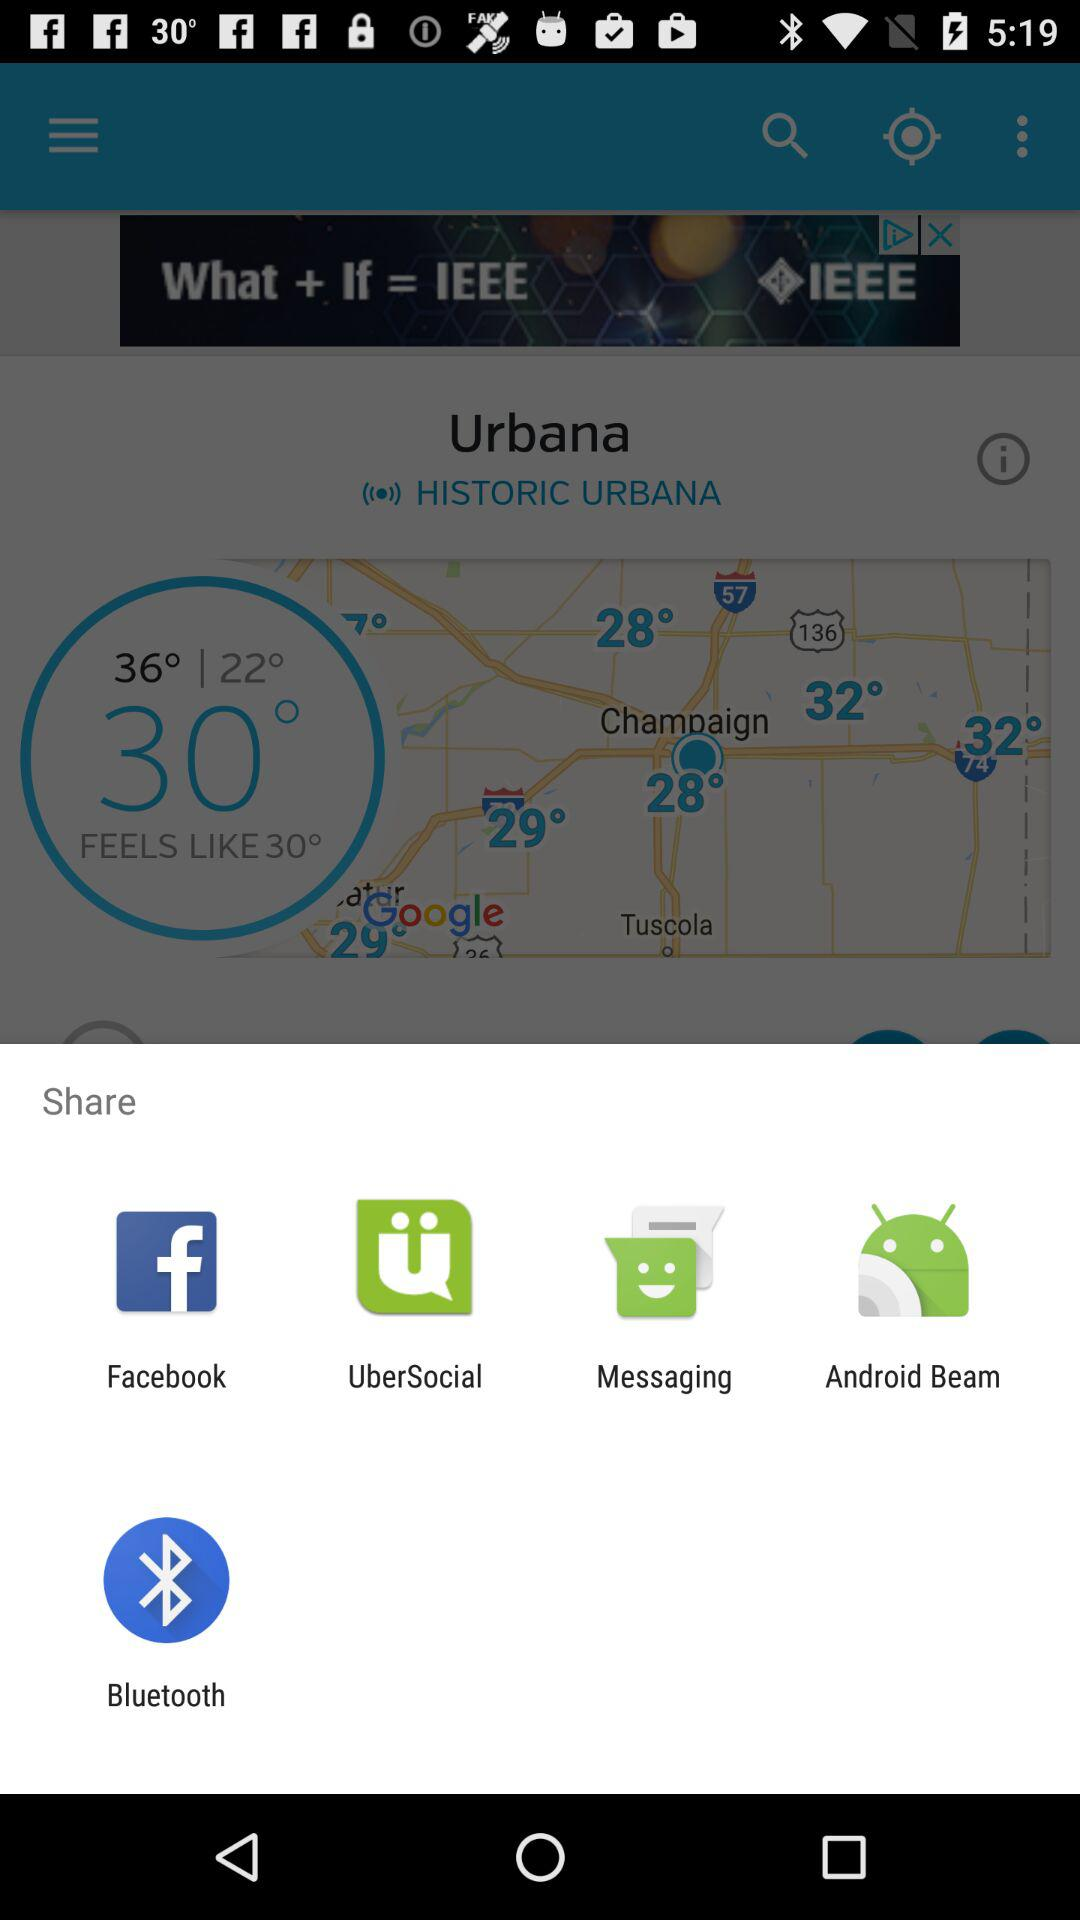Which application can be used to share? The applications that can be used to share are "Facebook", "UberSocial", "Messaging", "Android Beam" and "Bluetooth". 